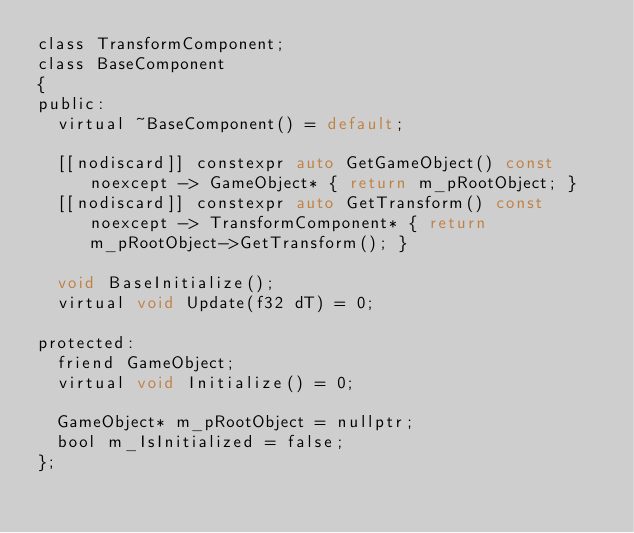Convert code to text. <code><loc_0><loc_0><loc_500><loc_500><_C_>class TransformComponent;
class BaseComponent
{
public:
	virtual ~BaseComponent() = default;

	[[nodiscard]] constexpr auto GetGameObject() const noexcept -> GameObject* { return m_pRootObject; }
	[[nodiscard]] constexpr auto GetTransform() const noexcept -> TransformComponent* { return m_pRootObject->GetTransform(); }

	void BaseInitialize();
	virtual void Update(f32 dT) = 0;

protected:
	friend GameObject;
	virtual void Initialize() = 0;

	GameObject* m_pRootObject = nullptr;
	bool m_IsInitialized = false;
};
</code> 